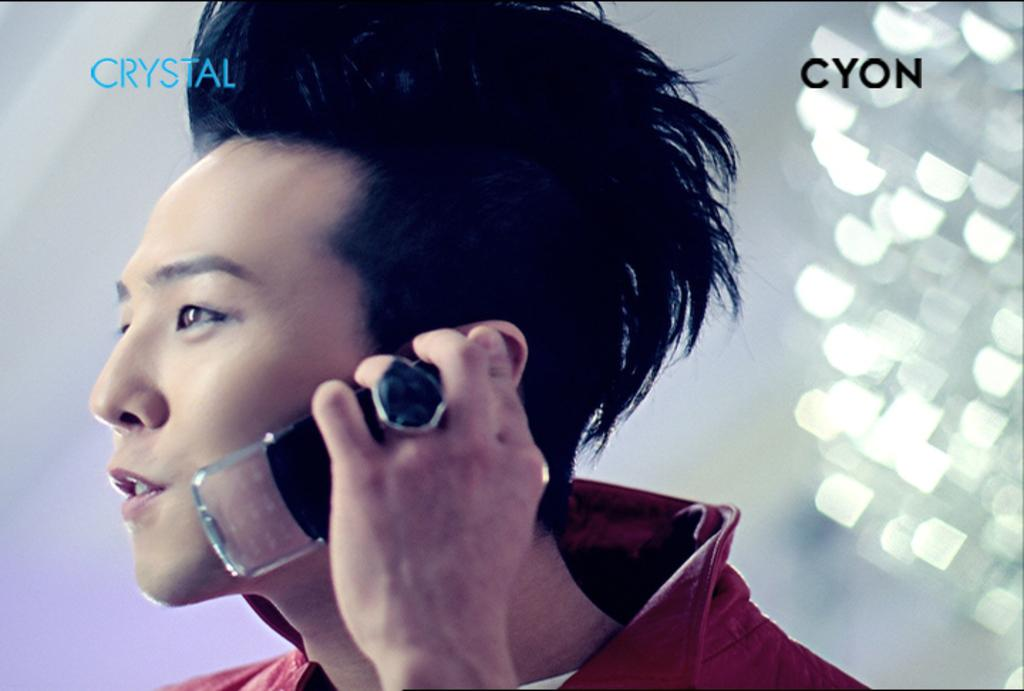<image>
Summarize the visual content of the image. A man holds a Crystal Cyon phone to his ear while wearing a large ring. 